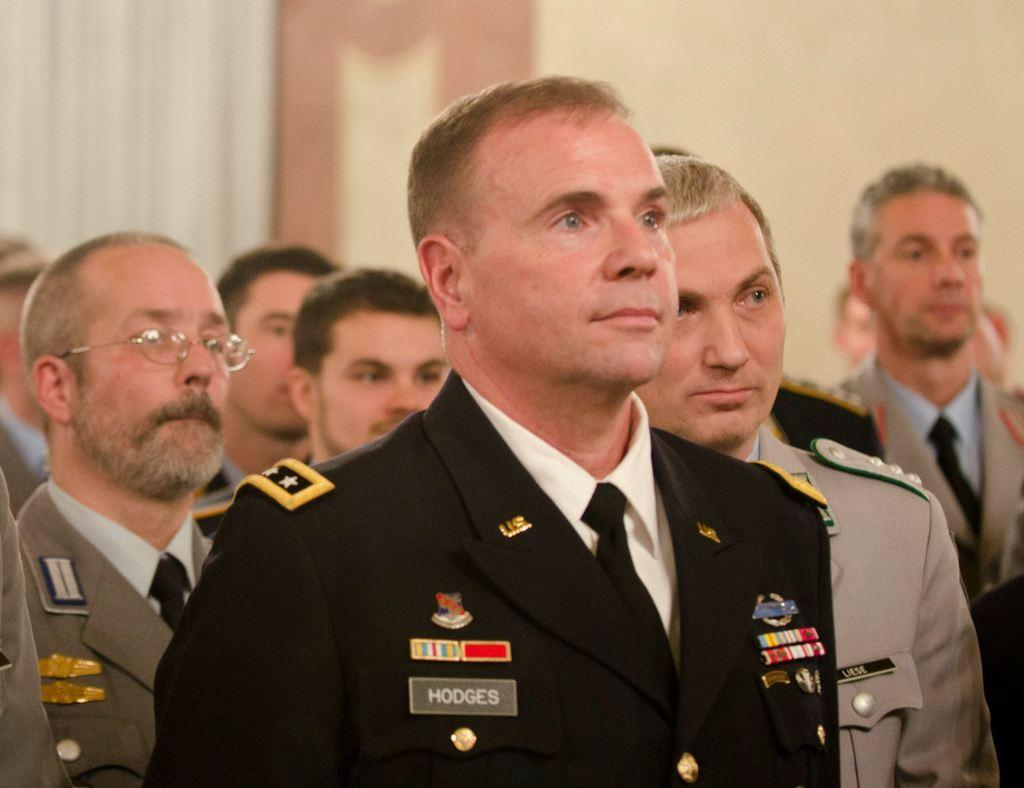What is the main subject of the image? The main subject of the image is a group of people. Can you describe the man on the left side of the image? The man on the left side of the image is wearing spectacles. How would you describe the background of the image? The background of the image is blurry. How many beggars can be seen in the image? There are no beggars present in the image. What type of boats can be seen in the image? There are no boats present in the image. 